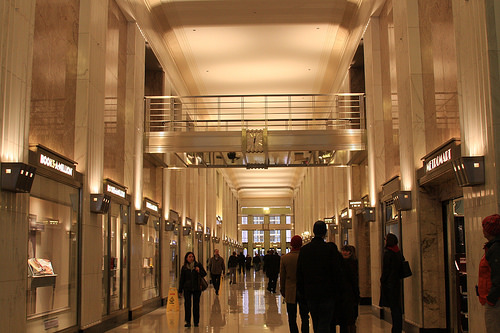<image>
Can you confirm if the lady is in front of the wall clock? Yes. The lady is positioned in front of the wall clock, appearing closer to the camera viewpoint. 